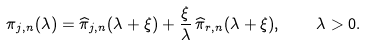Convert formula to latex. <formula><loc_0><loc_0><loc_500><loc_500>\pi _ { j , n } ( \lambda ) = \widehat { \pi } _ { j , n } ( \lambda + \xi ) + \frac { \xi } { \lambda } \, \widehat { \pi } _ { r , n } ( \lambda + \xi ) , \quad \lambda > 0 .</formula> 